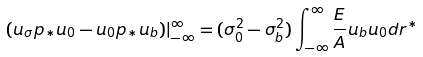Convert formula to latex. <formula><loc_0><loc_0><loc_500><loc_500>( u _ { \sigma } p _ { * } u _ { 0 } - u _ { 0 } p _ { * } u _ { b } ) | _ { - \infty } ^ { \infty } = ( \sigma _ { 0 } ^ { 2 } - \sigma _ { b } ^ { 2 } ) \int _ { - \infty } ^ { \infty } \frac { E } { A } u _ { b } u _ { 0 } d r ^ { * }</formula> 